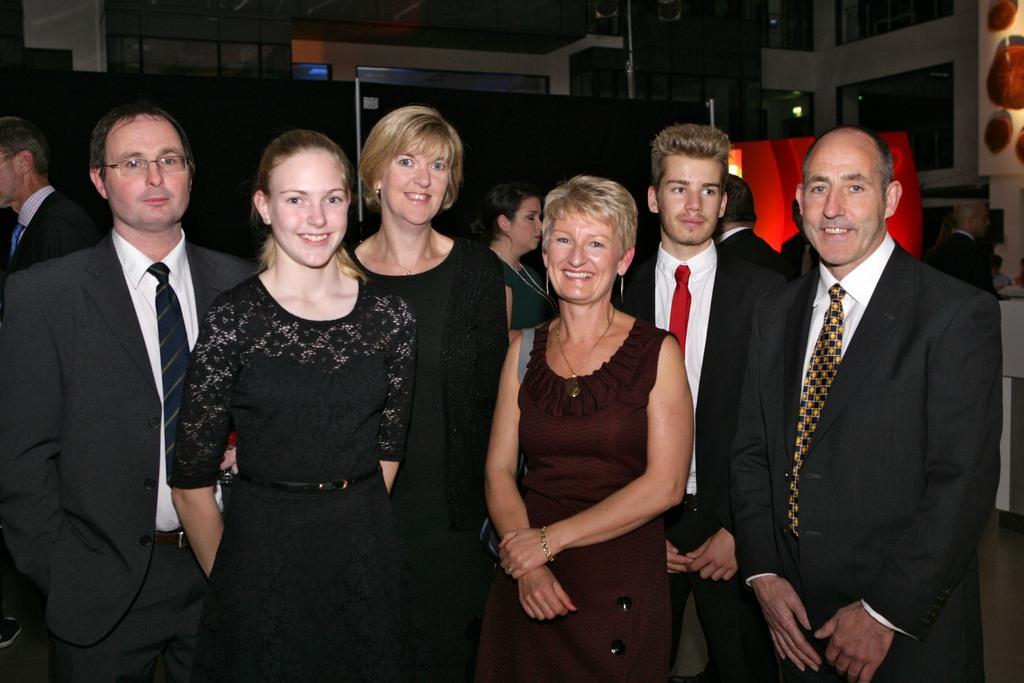How many people are in the image? There is a group of people standing in the image. What can be seen in the background of the image? The background of the image appears to be black. What is on the right side of the image? There are frames attached to a wall on the right side of the image. What type of drum is being played during the feast in the image? There is no drum or feast present in the image; it features a group of people standing in front of frames on a wall. 